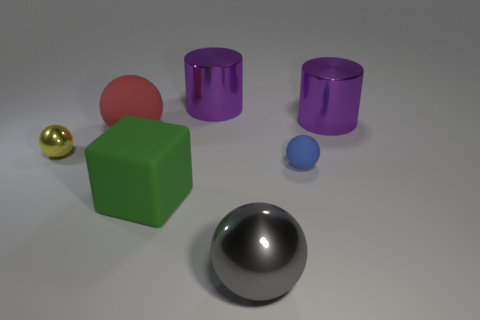Add 2 big gray objects. How many objects exist? 9 Subtract all brown balls. Subtract all gray cylinders. How many balls are left? 4 Subtract all cubes. How many objects are left? 6 Subtract 0 green cylinders. How many objects are left? 7 Subtract all rubber blocks. Subtract all gray metallic things. How many objects are left? 5 Add 2 red balls. How many red balls are left? 3 Add 4 shiny cylinders. How many shiny cylinders exist? 6 